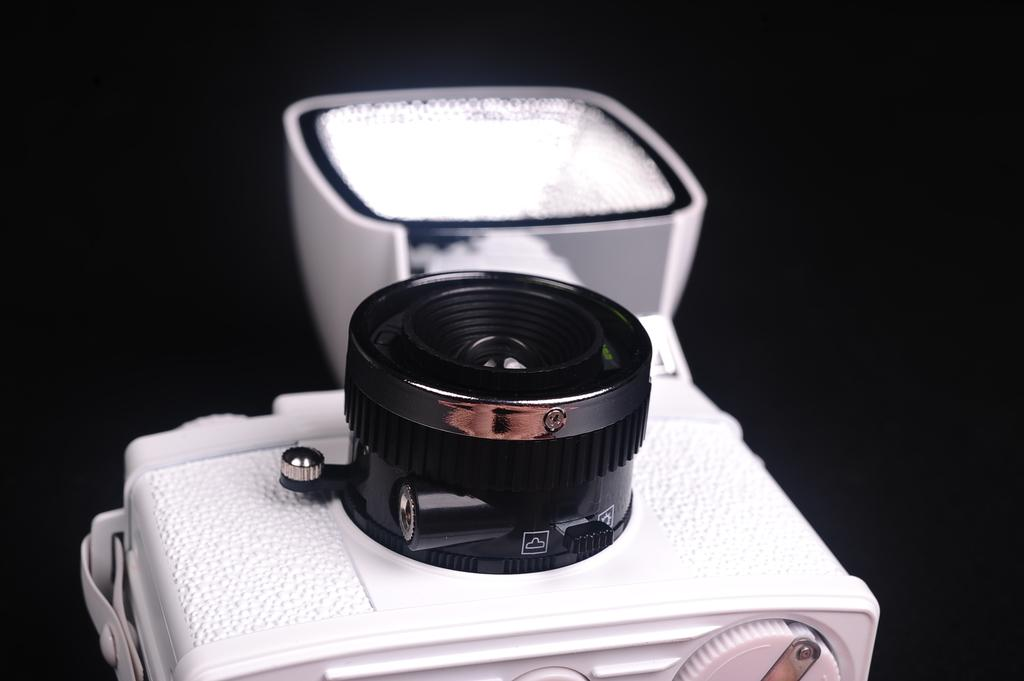What is the main object in the image? There is a camera in the image. Can you describe the background of the image? The background of the image is dark. What type of attraction can be seen in the background of the image? There is no attraction visible in the image; the background is dark. How does the laborer interact with the camera in the image? There is no laborer present in the image, only the camera. 